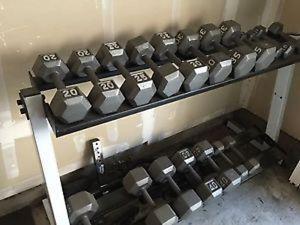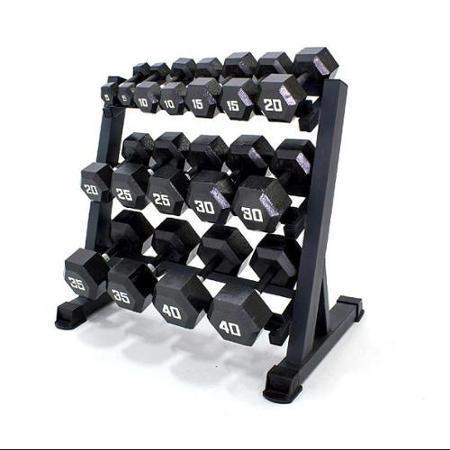The first image is the image on the left, the second image is the image on the right. Evaluate the accuracy of this statement regarding the images: "At least some of the weights in one of the pictures have red on them.". Is it true? Answer yes or no. No. The first image is the image on the left, the second image is the image on the right. Evaluate the accuracy of this statement regarding the images: "there is a weight racj with two rows of weights in the left image". Is it true? Answer yes or no. Yes. 